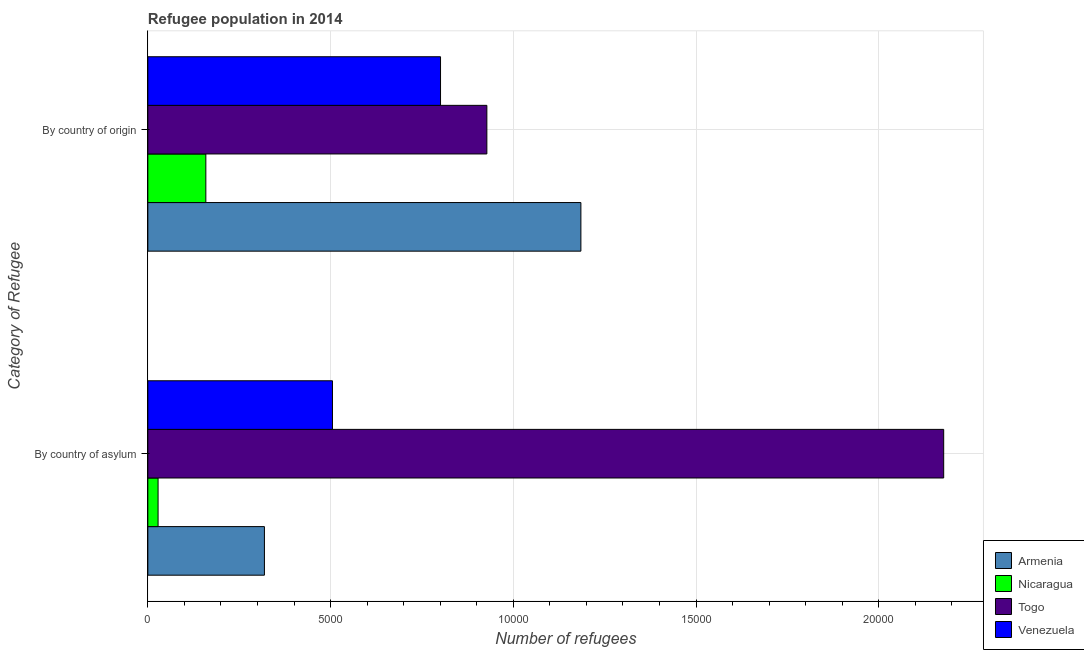Are the number of bars per tick equal to the number of legend labels?
Your answer should be compact. Yes. Are the number of bars on each tick of the Y-axis equal?
Offer a terse response. Yes. How many bars are there on the 2nd tick from the top?
Offer a very short reply. 4. How many bars are there on the 2nd tick from the bottom?
Your answer should be compact. 4. What is the label of the 2nd group of bars from the top?
Ensure brevity in your answer.  By country of asylum. What is the number of refugees by country of origin in Togo?
Your answer should be very brief. 9277. Across all countries, what is the maximum number of refugees by country of asylum?
Keep it short and to the point. 2.18e+04. Across all countries, what is the minimum number of refugees by country of origin?
Keep it short and to the point. 1587. In which country was the number of refugees by country of origin maximum?
Keep it short and to the point. Armenia. In which country was the number of refugees by country of origin minimum?
Keep it short and to the point. Nicaragua. What is the total number of refugees by country of asylum in the graph?
Your response must be concise. 3.03e+04. What is the difference between the number of refugees by country of origin in Armenia and that in Togo?
Make the answer very short. 2573. What is the difference between the number of refugees by country of origin in Venezuela and the number of refugees by country of asylum in Nicaragua?
Your response must be concise. 7729. What is the average number of refugees by country of origin per country?
Ensure brevity in your answer.  7680.75. What is the difference between the number of refugees by country of origin and number of refugees by country of asylum in Togo?
Ensure brevity in your answer.  -1.25e+04. What is the ratio of the number of refugees by country of origin in Nicaragua to that in Togo?
Ensure brevity in your answer.  0.17. Is the number of refugees by country of origin in Armenia less than that in Togo?
Give a very brief answer. No. In how many countries, is the number of refugees by country of origin greater than the average number of refugees by country of origin taken over all countries?
Make the answer very short. 3. What does the 1st bar from the top in By country of origin represents?
Give a very brief answer. Venezuela. What does the 3rd bar from the bottom in By country of asylum represents?
Your answer should be compact. Togo. How many bars are there?
Make the answer very short. 8. Are all the bars in the graph horizontal?
Your response must be concise. Yes. How many countries are there in the graph?
Ensure brevity in your answer.  4. What is the difference between two consecutive major ticks on the X-axis?
Provide a short and direct response. 5000. Does the graph contain any zero values?
Your answer should be very brief. No. How are the legend labels stacked?
Provide a short and direct response. Vertical. What is the title of the graph?
Provide a succinct answer. Refugee population in 2014. Does "Cambodia" appear as one of the legend labels in the graph?
Give a very brief answer. No. What is the label or title of the X-axis?
Provide a succinct answer. Number of refugees. What is the label or title of the Y-axis?
Provide a succinct answer. Category of Refugee. What is the Number of refugees in Armenia in By country of asylum?
Provide a succinct answer. 3190. What is the Number of refugees in Nicaragua in By country of asylum?
Provide a succinct answer. 280. What is the Number of refugees of Togo in By country of asylum?
Your answer should be very brief. 2.18e+04. What is the Number of refugees of Venezuela in By country of asylum?
Your answer should be compact. 5052. What is the Number of refugees of Armenia in By country of origin?
Keep it short and to the point. 1.18e+04. What is the Number of refugees of Nicaragua in By country of origin?
Give a very brief answer. 1587. What is the Number of refugees in Togo in By country of origin?
Give a very brief answer. 9277. What is the Number of refugees of Venezuela in By country of origin?
Your response must be concise. 8009. Across all Category of Refugee, what is the maximum Number of refugees in Armenia?
Provide a short and direct response. 1.18e+04. Across all Category of Refugee, what is the maximum Number of refugees of Nicaragua?
Offer a terse response. 1587. Across all Category of Refugee, what is the maximum Number of refugees in Togo?
Make the answer very short. 2.18e+04. Across all Category of Refugee, what is the maximum Number of refugees of Venezuela?
Make the answer very short. 8009. Across all Category of Refugee, what is the minimum Number of refugees of Armenia?
Provide a succinct answer. 3190. Across all Category of Refugee, what is the minimum Number of refugees of Nicaragua?
Provide a succinct answer. 280. Across all Category of Refugee, what is the minimum Number of refugees in Togo?
Make the answer very short. 9277. Across all Category of Refugee, what is the minimum Number of refugees in Venezuela?
Ensure brevity in your answer.  5052. What is the total Number of refugees of Armenia in the graph?
Ensure brevity in your answer.  1.50e+04. What is the total Number of refugees of Nicaragua in the graph?
Provide a short and direct response. 1867. What is the total Number of refugees in Togo in the graph?
Ensure brevity in your answer.  3.11e+04. What is the total Number of refugees in Venezuela in the graph?
Provide a short and direct response. 1.31e+04. What is the difference between the Number of refugees of Armenia in By country of asylum and that in By country of origin?
Offer a very short reply. -8660. What is the difference between the Number of refugees of Nicaragua in By country of asylum and that in By country of origin?
Give a very brief answer. -1307. What is the difference between the Number of refugees of Togo in By country of asylum and that in By country of origin?
Give a very brief answer. 1.25e+04. What is the difference between the Number of refugees in Venezuela in By country of asylum and that in By country of origin?
Make the answer very short. -2957. What is the difference between the Number of refugees of Armenia in By country of asylum and the Number of refugees of Nicaragua in By country of origin?
Provide a short and direct response. 1603. What is the difference between the Number of refugees of Armenia in By country of asylum and the Number of refugees of Togo in By country of origin?
Make the answer very short. -6087. What is the difference between the Number of refugees of Armenia in By country of asylum and the Number of refugees of Venezuela in By country of origin?
Provide a short and direct response. -4819. What is the difference between the Number of refugees of Nicaragua in By country of asylum and the Number of refugees of Togo in By country of origin?
Offer a very short reply. -8997. What is the difference between the Number of refugees in Nicaragua in By country of asylum and the Number of refugees in Venezuela in By country of origin?
Keep it short and to the point. -7729. What is the difference between the Number of refugees of Togo in By country of asylum and the Number of refugees of Venezuela in By country of origin?
Give a very brief answer. 1.38e+04. What is the average Number of refugees in Armenia per Category of Refugee?
Make the answer very short. 7520. What is the average Number of refugees in Nicaragua per Category of Refugee?
Provide a succinct answer. 933.5. What is the average Number of refugees in Togo per Category of Refugee?
Ensure brevity in your answer.  1.55e+04. What is the average Number of refugees in Venezuela per Category of Refugee?
Give a very brief answer. 6530.5. What is the difference between the Number of refugees in Armenia and Number of refugees in Nicaragua in By country of asylum?
Provide a short and direct response. 2910. What is the difference between the Number of refugees in Armenia and Number of refugees in Togo in By country of asylum?
Give a very brief answer. -1.86e+04. What is the difference between the Number of refugees in Armenia and Number of refugees in Venezuela in By country of asylum?
Offer a very short reply. -1862. What is the difference between the Number of refugees of Nicaragua and Number of refugees of Togo in By country of asylum?
Your answer should be very brief. -2.15e+04. What is the difference between the Number of refugees in Nicaragua and Number of refugees in Venezuela in By country of asylum?
Offer a very short reply. -4772. What is the difference between the Number of refugees in Togo and Number of refugees in Venezuela in By country of asylum?
Offer a very short reply. 1.67e+04. What is the difference between the Number of refugees of Armenia and Number of refugees of Nicaragua in By country of origin?
Offer a terse response. 1.03e+04. What is the difference between the Number of refugees in Armenia and Number of refugees in Togo in By country of origin?
Your answer should be compact. 2573. What is the difference between the Number of refugees of Armenia and Number of refugees of Venezuela in By country of origin?
Your response must be concise. 3841. What is the difference between the Number of refugees in Nicaragua and Number of refugees in Togo in By country of origin?
Your answer should be very brief. -7690. What is the difference between the Number of refugees in Nicaragua and Number of refugees in Venezuela in By country of origin?
Make the answer very short. -6422. What is the difference between the Number of refugees of Togo and Number of refugees of Venezuela in By country of origin?
Make the answer very short. 1268. What is the ratio of the Number of refugees in Armenia in By country of asylum to that in By country of origin?
Keep it short and to the point. 0.27. What is the ratio of the Number of refugees in Nicaragua in By country of asylum to that in By country of origin?
Your answer should be compact. 0.18. What is the ratio of the Number of refugees of Togo in By country of asylum to that in By country of origin?
Provide a short and direct response. 2.35. What is the ratio of the Number of refugees in Venezuela in By country of asylum to that in By country of origin?
Ensure brevity in your answer.  0.63. What is the difference between the highest and the second highest Number of refugees of Armenia?
Provide a succinct answer. 8660. What is the difference between the highest and the second highest Number of refugees of Nicaragua?
Give a very brief answer. 1307. What is the difference between the highest and the second highest Number of refugees in Togo?
Make the answer very short. 1.25e+04. What is the difference between the highest and the second highest Number of refugees of Venezuela?
Provide a succinct answer. 2957. What is the difference between the highest and the lowest Number of refugees of Armenia?
Give a very brief answer. 8660. What is the difference between the highest and the lowest Number of refugees of Nicaragua?
Your response must be concise. 1307. What is the difference between the highest and the lowest Number of refugees of Togo?
Your response must be concise. 1.25e+04. What is the difference between the highest and the lowest Number of refugees in Venezuela?
Your response must be concise. 2957. 